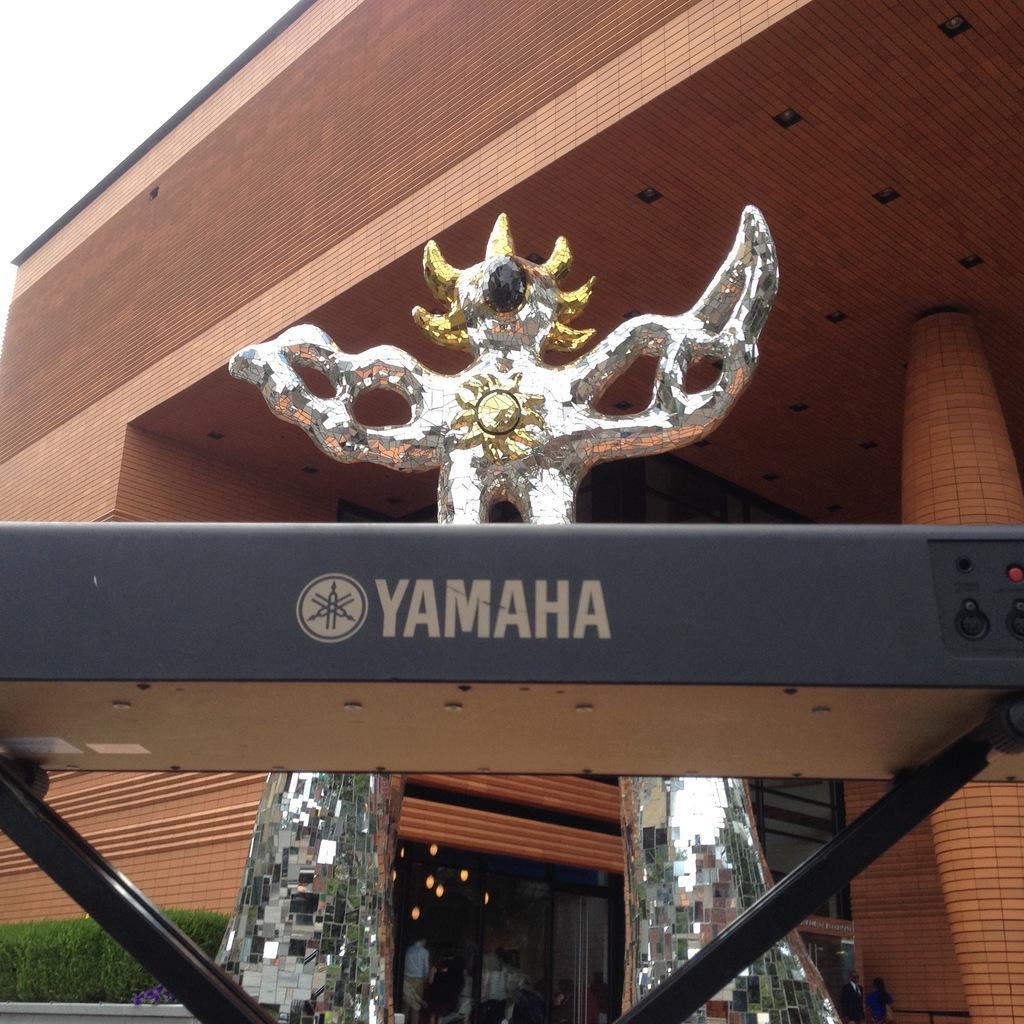Could you give a brief overview of what you see in this image? In the foreground I can see a fence, sculpture, plants, group of people on the road and a building. On the top left I can see the sky. This image is taken during a day. 